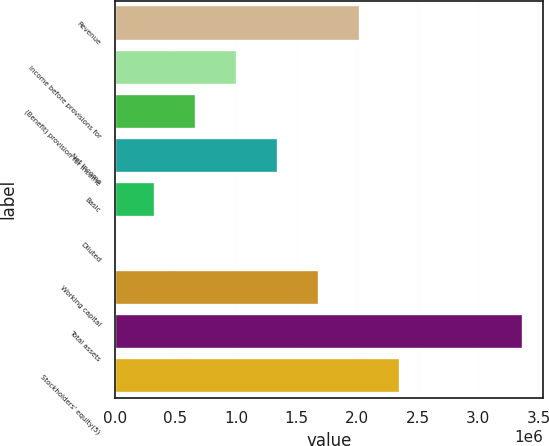<chart> <loc_0><loc_0><loc_500><loc_500><bar_chart><fcel>Revenue<fcel>Income before provisions for<fcel>(Benefit) provision for income<fcel>Net income<fcel>Basic<fcel>Diluted<fcel>Working capital<fcel>Total assets<fcel>Stockholders' equity(5)<nl><fcel>2.0204e+06<fcel>1.0102e+06<fcel>673468<fcel>1.34693e+06<fcel>336735<fcel>1.47<fcel>1.68367e+06<fcel>3.36733e+06<fcel>2.35713e+06<nl></chart> 